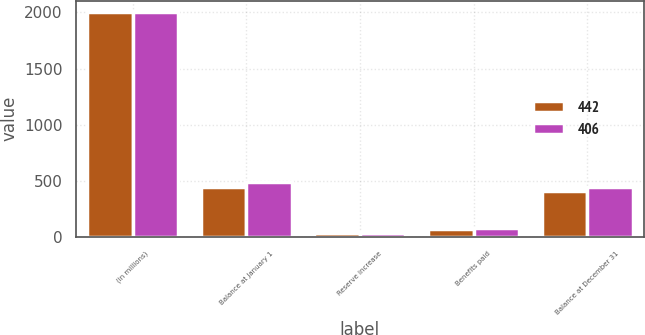Convert chart. <chart><loc_0><loc_0><loc_500><loc_500><stacked_bar_chart><ecel><fcel>(in millions)<fcel>Balance at January 1<fcel>Reserve increase<fcel>Benefits paid<fcel>Balance at December 31<nl><fcel>442<fcel>2006<fcel>442<fcel>35<fcel>71<fcel>406<nl><fcel>406<fcel>2005<fcel>485<fcel>33<fcel>76<fcel>442<nl></chart> 